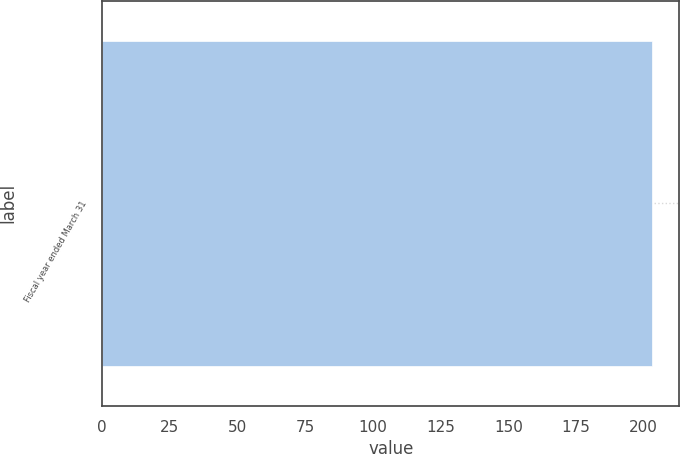<chart> <loc_0><loc_0><loc_500><loc_500><bar_chart><fcel>Fiscal year ended March 31<nl><fcel>203<nl></chart> 